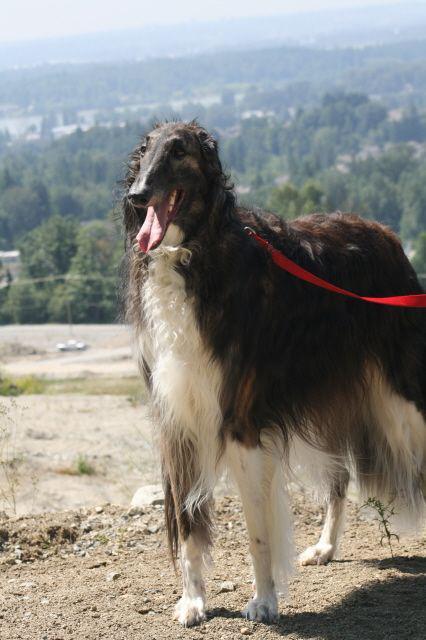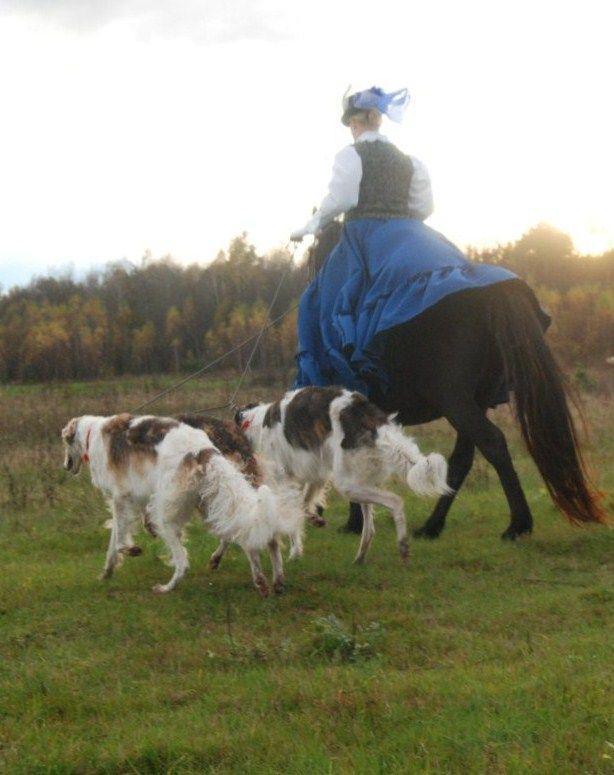The first image is the image on the left, the second image is the image on the right. Analyze the images presented: Is the assertion "There is at least 1 black and white dog that is not facing right." valid? Answer yes or no. Yes. The first image is the image on the left, the second image is the image on the right. For the images shown, is this caption "A long-haired dog with a thin face is standing with no other dogs." true? Answer yes or no. Yes. 